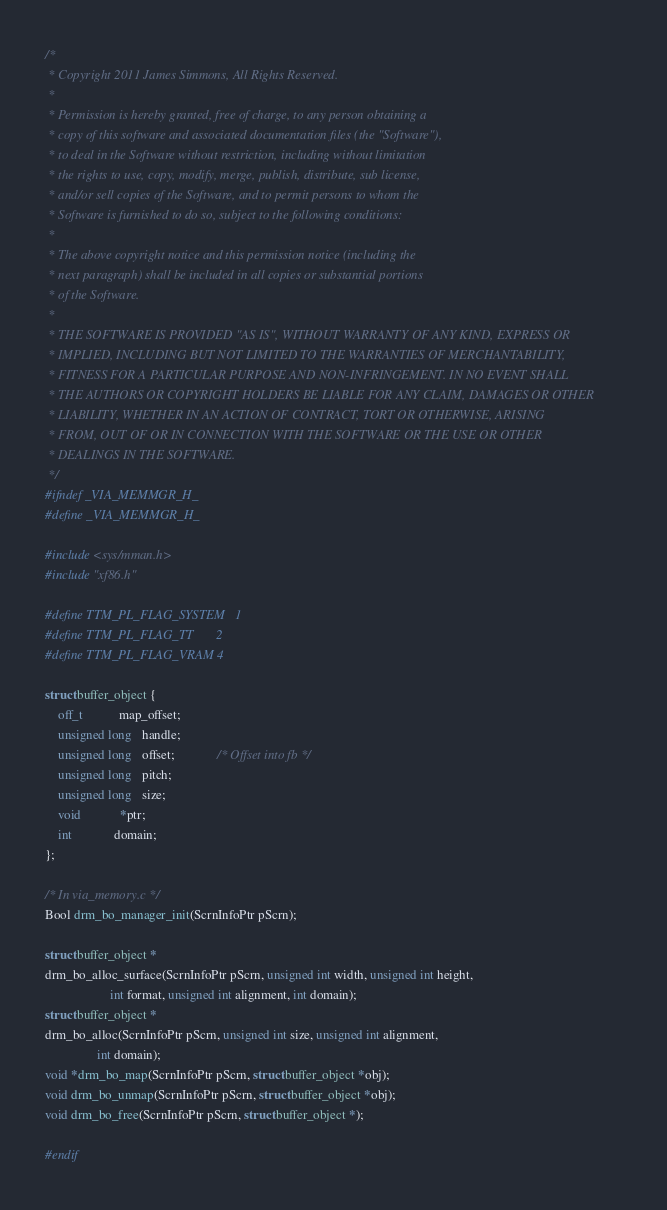<code> <loc_0><loc_0><loc_500><loc_500><_C_>/*
 * Copyright 2011 James Simmons, All Rights Reserved.
 *
 * Permission is hereby granted, free of charge, to any person obtaining a
 * copy of this software and associated documentation files (the "Software"),
 * to deal in the Software without restriction, including without limitation
 * the rights to use, copy, modify, merge, publish, distribute, sub license,
 * and/or sell copies of the Software, and to permit persons to whom the
 * Software is furnished to do so, subject to the following conditions:
 *
 * The above copyright notice and this permission notice (including the
 * next paragraph) shall be included in all copies or substantial portions
 * of the Software.
 *
 * THE SOFTWARE IS PROVIDED "AS IS", WITHOUT WARRANTY OF ANY KIND, EXPRESS OR
 * IMPLIED, INCLUDING BUT NOT LIMITED TO THE WARRANTIES OF MERCHANTABILITY,
 * FITNESS FOR A PARTICULAR PURPOSE AND NON-INFRINGEMENT. IN NO EVENT SHALL
 * THE AUTHORS OR COPYRIGHT HOLDERS BE LIABLE FOR ANY CLAIM, DAMAGES OR OTHER
 * LIABILITY, WHETHER IN AN ACTION OF CONTRACT, TORT OR OTHERWISE, ARISING
 * FROM, OUT OF OR IN CONNECTION WITH THE SOFTWARE OR THE USE OR OTHER
 * DEALINGS IN THE SOFTWARE.
 */
#ifndef _VIA_MEMMGR_H_
#define _VIA_MEMMGR_H_

#include <sys/mman.h>
#include "xf86.h"

#define TTM_PL_FLAG_SYSTEM	1
#define TTM_PL_FLAG_TT		2
#define TTM_PL_FLAG_VRAM	4

struct buffer_object {
    off_t           map_offset;
    unsigned long   handle;
    unsigned long   offset;             /* Offset into fb */
    unsigned long   pitch;
    unsigned long   size;
    void            *ptr;
    int             domain;
};

/* In via_memory.c */
Bool drm_bo_manager_init(ScrnInfoPtr pScrn);

struct buffer_object *
drm_bo_alloc_surface(ScrnInfoPtr pScrn, unsigned int width, unsigned int height,
                    int format, unsigned int alignment, int domain);
struct buffer_object *
drm_bo_alloc(ScrnInfoPtr pScrn, unsigned int size, unsigned int alignment,
                int domain);
void *drm_bo_map(ScrnInfoPtr pScrn, struct buffer_object *obj);
void drm_bo_unmap(ScrnInfoPtr pScrn, struct buffer_object *obj);
void drm_bo_free(ScrnInfoPtr pScrn, struct buffer_object *);

#endif
</code> 